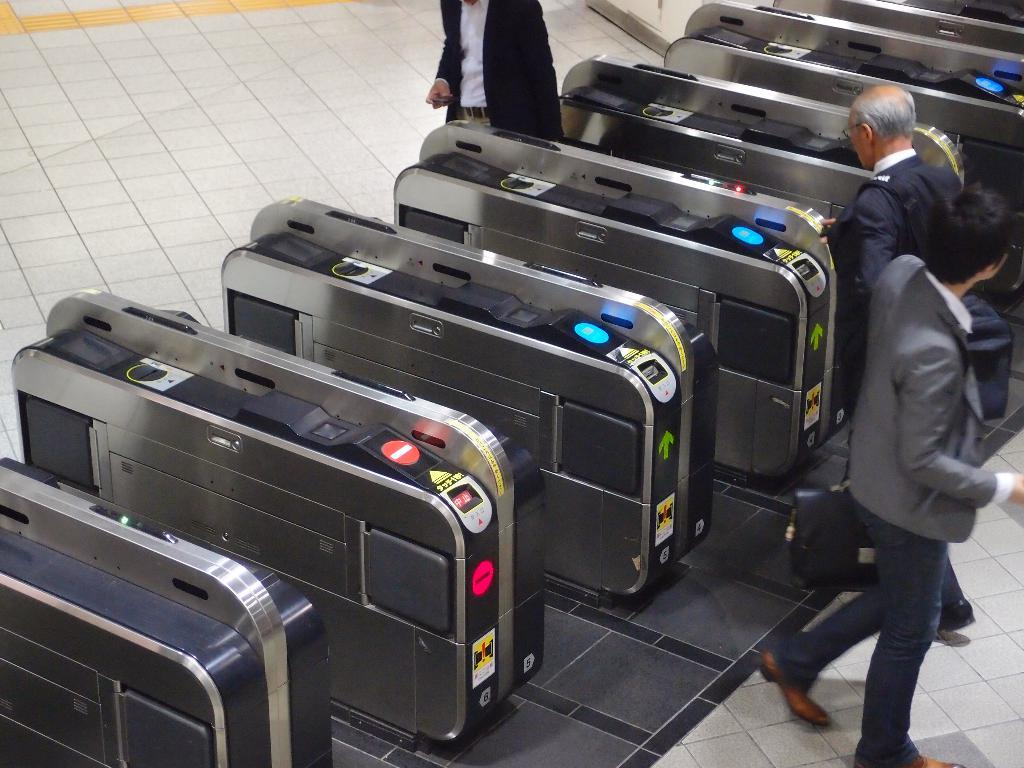How many people are in the image? There are three men in the image. What are the men doing in the image? The men are walking in the image. What else can be seen in the image besides the men? There are machines located on the left side of the image. What type of brush is being used by the men in the image? There is no brush present in the image; the men are walking. How does the image show respect for the machines? The image does not show respect for the machines; it simply depicts the men walking and the machines located on the left side. 